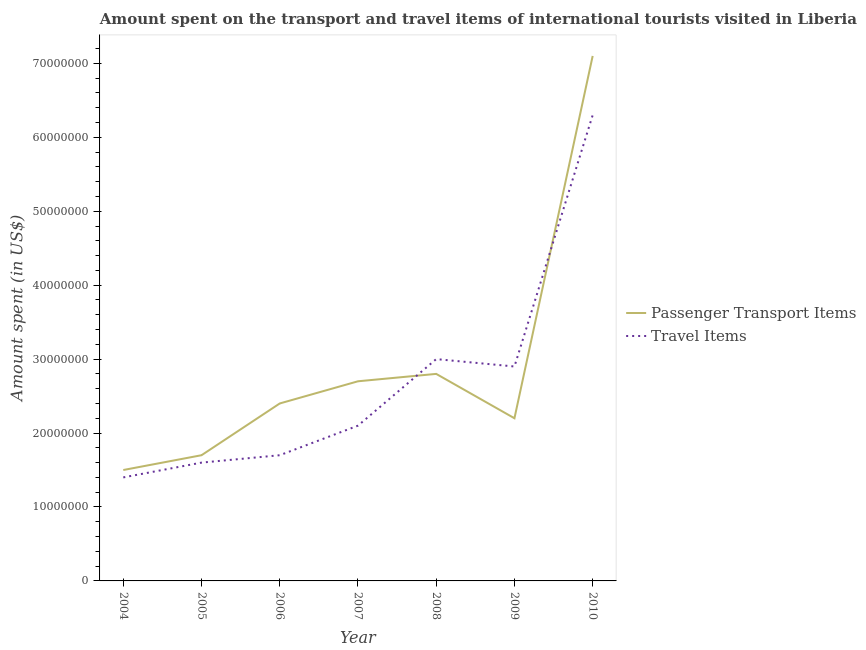How many different coloured lines are there?
Offer a terse response. 2. Is the number of lines equal to the number of legend labels?
Your answer should be very brief. Yes. What is the amount spent on passenger transport items in 2009?
Your response must be concise. 2.20e+07. Across all years, what is the maximum amount spent in travel items?
Your response must be concise. 6.30e+07. Across all years, what is the minimum amount spent in travel items?
Ensure brevity in your answer.  1.40e+07. In which year was the amount spent on passenger transport items maximum?
Your answer should be compact. 2010. In which year was the amount spent in travel items minimum?
Keep it short and to the point. 2004. What is the total amount spent in travel items in the graph?
Ensure brevity in your answer.  1.90e+08. What is the difference between the amount spent in travel items in 2008 and that in 2010?
Ensure brevity in your answer.  -3.30e+07. What is the difference between the amount spent in travel items in 2004 and the amount spent on passenger transport items in 2010?
Offer a terse response. -5.70e+07. What is the average amount spent on passenger transport items per year?
Give a very brief answer. 2.91e+07. In the year 2010, what is the difference between the amount spent on passenger transport items and amount spent in travel items?
Offer a very short reply. 8.00e+06. In how many years, is the amount spent on passenger transport items greater than 8000000 US$?
Your response must be concise. 7. What is the ratio of the amount spent in travel items in 2005 to that in 2006?
Provide a succinct answer. 0.94. Is the amount spent on passenger transport items in 2004 less than that in 2007?
Provide a short and direct response. Yes. What is the difference between the highest and the second highest amount spent in travel items?
Your answer should be compact. 3.30e+07. What is the difference between the highest and the lowest amount spent in travel items?
Offer a very short reply. 4.90e+07. In how many years, is the amount spent on passenger transport items greater than the average amount spent on passenger transport items taken over all years?
Your response must be concise. 1. Is the sum of the amount spent in travel items in 2005 and 2007 greater than the maximum amount spent on passenger transport items across all years?
Make the answer very short. No. Is the amount spent on passenger transport items strictly greater than the amount spent in travel items over the years?
Your answer should be compact. No. Is the amount spent in travel items strictly less than the amount spent on passenger transport items over the years?
Your answer should be compact. No. How many lines are there?
Offer a very short reply. 2. How many years are there in the graph?
Your answer should be compact. 7. Does the graph contain any zero values?
Provide a short and direct response. No. Does the graph contain grids?
Offer a very short reply. No. What is the title of the graph?
Keep it short and to the point. Amount spent on the transport and travel items of international tourists visited in Liberia. Does "Quality of trade" appear as one of the legend labels in the graph?
Offer a terse response. No. What is the label or title of the Y-axis?
Offer a terse response. Amount spent (in US$). What is the Amount spent (in US$) of Passenger Transport Items in 2004?
Your response must be concise. 1.50e+07. What is the Amount spent (in US$) in Travel Items in 2004?
Provide a succinct answer. 1.40e+07. What is the Amount spent (in US$) in Passenger Transport Items in 2005?
Make the answer very short. 1.70e+07. What is the Amount spent (in US$) in Travel Items in 2005?
Provide a short and direct response. 1.60e+07. What is the Amount spent (in US$) in Passenger Transport Items in 2006?
Offer a very short reply. 2.40e+07. What is the Amount spent (in US$) in Travel Items in 2006?
Make the answer very short. 1.70e+07. What is the Amount spent (in US$) of Passenger Transport Items in 2007?
Your answer should be very brief. 2.70e+07. What is the Amount spent (in US$) in Travel Items in 2007?
Your response must be concise. 2.10e+07. What is the Amount spent (in US$) of Passenger Transport Items in 2008?
Provide a succinct answer. 2.80e+07. What is the Amount spent (in US$) in Travel Items in 2008?
Provide a short and direct response. 3.00e+07. What is the Amount spent (in US$) of Passenger Transport Items in 2009?
Offer a terse response. 2.20e+07. What is the Amount spent (in US$) of Travel Items in 2009?
Your answer should be compact. 2.90e+07. What is the Amount spent (in US$) in Passenger Transport Items in 2010?
Ensure brevity in your answer.  7.10e+07. What is the Amount spent (in US$) in Travel Items in 2010?
Offer a very short reply. 6.30e+07. Across all years, what is the maximum Amount spent (in US$) of Passenger Transport Items?
Provide a short and direct response. 7.10e+07. Across all years, what is the maximum Amount spent (in US$) in Travel Items?
Offer a very short reply. 6.30e+07. Across all years, what is the minimum Amount spent (in US$) in Passenger Transport Items?
Your answer should be compact. 1.50e+07. Across all years, what is the minimum Amount spent (in US$) in Travel Items?
Offer a very short reply. 1.40e+07. What is the total Amount spent (in US$) in Passenger Transport Items in the graph?
Provide a short and direct response. 2.04e+08. What is the total Amount spent (in US$) in Travel Items in the graph?
Keep it short and to the point. 1.90e+08. What is the difference between the Amount spent (in US$) of Passenger Transport Items in 2004 and that in 2006?
Make the answer very short. -9.00e+06. What is the difference between the Amount spent (in US$) of Passenger Transport Items in 2004 and that in 2007?
Offer a terse response. -1.20e+07. What is the difference between the Amount spent (in US$) in Travel Items in 2004 and that in 2007?
Keep it short and to the point. -7.00e+06. What is the difference between the Amount spent (in US$) in Passenger Transport Items in 2004 and that in 2008?
Provide a short and direct response. -1.30e+07. What is the difference between the Amount spent (in US$) of Travel Items in 2004 and that in 2008?
Offer a terse response. -1.60e+07. What is the difference between the Amount spent (in US$) of Passenger Transport Items in 2004 and that in 2009?
Provide a succinct answer. -7.00e+06. What is the difference between the Amount spent (in US$) of Travel Items in 2004 and that in 2009?
Your response must be concise. -1.50e+07. What is the difference between the Amount spent (in US$) of Passenger Transport Items in 2004 and that in 2010?
Your answer should be compact. -5.60e+07. What is the difference between the Amount spent (in US$) in Travel Items in 2004 and that in 2010?
Your answer should be very brief. -4.90e+07. What is the difference between the Amount spent (in US$) of Passenger Transport Items in 2005 and that in 2006?
Keep it short and to the point. -7.00e+06. What is the difference between the Amount spent (in US$) in Passenger Transport Items in 2005 and that in 2007?
Make the answer very short. -1.00e+07. What is the difference between the Amount spent (in US$) in Travel Items in 2005 and that in 2007?
Provide a succinct answer. -5.00e+06. What is the difference between the Amount spent (in US$) of Passenger Transport Items in 2005 and that in 2008?
Offer a very short reply. -1.10e+07. What is the difference between the Amount spent (in US$) in Travel Items in 2005 and that in 2008?
Offer a very short reply. -1.40e+07. What is the difference between the Amount spent (in US$) in Passenger Transport Items in 2005 and that in 2009?
Your answer should be compact. -5.00e+06. What is the difference between the Amount spent (in US$) of Travel Items in 2005 and that in 2009?
Your answer should be very brief. -1.30e+07. What is the difference between the Amount spent (in US$) in Passenger Transport Items in 2005 and that in 2010?
Provide a succinct answer. -5.40e+07. What is the difference between the Amount spent (in US$) of Travel Items in 2005 and that in 2010?
Offer a terse response. -4.70e+07. What is the difference between the Amount spent (in US$) of Travel Items in 2006 and that in 2007?
Ensure brevity in your answer.  -4.00e+06. What is the difference between the Amount spent (in US$) of Travel Items in 2006 and that in 2008?
Provide a short and direct response. -1.30e+07. What is the difference between the Amount spent (in US$) in Travel Items in 2006 and that in 2009?
Give a very brief answer. -1.20e+07. What is the difference between the Amount spent (in US$) in Passenger Transport Items in 2006 and that in 2010?
Give a very brief answer. -4.70e+07. What is the difference between the Amount spent (in US$) of Travel Items in 2006 and that in 2010?
Ensure brevity in your answer.  -4.60e+07. What is the difference between the Amount spent (in US$) in Passenger Transport Items in 2007 and that in 2008?
Ensure brevity in your answer.  -1.00e+06. What is the difference between the Amount spent (in US$) of Travel Items in 2007 and that in 2008?
Make the answer very short. -9.00e+06. What is the difference between the Amount spent (in US$) in Travel Items in 2007 and that in 2009?
Give a very brief answer. -8.00e+06. What is the difference between the Amount spent (in US$) in Passenger Transport Items in 2007 and that in 2010?
Provide a succinct answer. -4.40e+07. What is the difference between the Amount spent (in US$) of Travel Items in 2007 and that in 2010?
Give a very brief answer. -4.20e+07. What is the difference between the Amount spent (in US$) of Passenger Transport Items in 2008 and that in 2010?
Offer a very short reply. -4.30e+07. What is the difference between the Amount spent (in US$) in Travel Items in 2008 and that in 2010?
Ensure brevity in your answer.  -3.30e+07. What is the difference between the Amount spent (in US$) of Passenger Transport Items in 2009 and that in 2010?
Make the answer very short. -4.90e+07. What is the difference between the Amount spent (in US$) of Travel Items in 2009 and that in 2010?
Offer a terse response. -3.40e+07. What is the difference between the Amount spent (in US$) of Passenger Transport Items in 2004 and the Amount spent (in US$) of Travel Items in 2006?
Your answer should be compact. -2.00e+06. What is the difference between the Amount spent (in US$) in Passenger Transport Items in 2004 and the Amount spent (in US$) in Travel Items in 2007?
Provide a short and direct response. -6.00e+06. What is the difference between the Amount spent (in US$) in Passenger Transport Items in 2004 and the Amount spent (in US$) in Travel Items in 2008?
Your response must be concise. -1.50e+07. What is the difference between the Amount spent (in US$) in Passenger Transport Items in 2004 and the Amount spent (in US$) in Travel Items in 2009?
Provide a succinct answer. -1.40e+07. What is the difference between the Amount spent (in US$) of Passenger Transport Items in 2004 and the Amount spent (in US$) of Travel Items in 2010?
Ensure brevity in your answer.  -4.80e+07. What is the difference between the Amount spent (in US$) in Passenger Transport Items in 2005 and the Amount spent (in US$) in Travel Items in 2006?
Your response must be concise. 0. What is the difference between the Amount spent (in US$) in Passenger Transport Items in 2005 and the Amount spent (in US$) in Travel Items in 2008?
Offer a very short reply. -1.30e+07. What is the difference between the Amount spent (in US$) in Passenger Transport Items in 2005 and the Amount spent (in US$) in Travel Items in 2009?
Give a very brief answer. -1.20e+07. What is the difference between the Amount spent (in US$) of Passenger Transport Items in 2005 and the Amount spent (in US$) of Travel Items in 2010?
Your answer should be very brief. -4.60e+07. What is the difference between the Amount spent (in US$) of Passenger Transport Items in 2006 and the Amount spent (in US$) of Travel Items in 2007?
Give a very brief answer. 3.00e+06. What is the difference between the Amount spent (in US$) of Passenger Transport Items in 2006 and the Amount spent (in US$) of Travel Items in 2008?
Offer a terse response. -6.00e+06. What is the difference between the Amount spent (in US$) of Passenger Transport Items in 2006 and the Amount spent (in US$) of Travel Items in 2009?
Make the answer very short. -5.00e+06. What is the difference between the Amount spent (in US$) of Passenger Transport Items in 2006 and the Amount spent (in US$) of Travel Items in 2010?
Give a very brief answer. -3.90e+07. What is the difference between the Amount spent (in US$) of Passenger Transport Items in 2007 and the Amount spent (in US$) of Travel Items in 2010?
Give a very brief answer. -3.60e+07. What is the difference between the Amount spent (in US$) of Passenger Transport Items in 2008 and the Amount spent (in US$) of Travel Items in 2010?
Make the answer very short. -3.50e+07. What is the difference between the Amount spent (in US$) of Passenger Transport Items in 2009 and the Amount spent (in US$) of Travel Items in 2010?
Give a very brief answer. -4.10e+07. What is the average Amount spent (in US$) in Passenger Transport Items per year?
Give a very brief answer. 2.91e+07. What is the average Amount spent (in US$) in Travel Items per year?
Ensure brevity in your answer.  2.71e+07. In the year 2005, what is the difference between the Amount spent (in US$) of Passenger Transport Items and Amount spent (in US$) of Travel Items?
Provide a succinct answer. 1.00e+06. In the year 2006, what is the difference between the Amount spent (in US$) of Passenger Transport Items and Amount spent (in US$) of Travel Items?
Ensure brevity in your answer.  7.00e+06. In the year 2008, what is the difference between the Amount spent (in US$) of Passenger Transport Items and Amount spent (in US$) of Travel Items?
Offer a terse response. -2.00e+06. In the year 2009, what is the difference between the Amount spent (in US$) of Passenger Transport Items and Amount spent (in US$) of Travel Items?
Ensure brevity in your answer.  -7.00e+06. In the year 2010, what is the difference between the Amount spent (in US$) in Passenger Transport Items and Amount spent (in US$) in Travel Items?
Provide a succinct answer. 8.00e+06. What is the ratio of the Amount spent (in US$) in Passenger Transport Items in 2004 to that in 2005?
Offer a terse response. 0.88. What is the ratio of the Amount spent (in US$) of Travel Items in 2004 to that in 2005?
Ensure brevity in your answer.  0.88. What is the ratio of the Amount spent (in US$) in Passenger Transport Items in 2004 to that in 2006?
Keep it short and to the point. 0.62. What is the ratio of the Amount spent (in US$) of Travel Items in 2004 to that in 2006?
Provide a short and direct response. 0.82. What is the ratio of the Amount spent (in US$) in Passenger Transport Items in 2004 to that in 2007?
Your answer should be compact. 0.56. What is the ratio of the Amount spent (in US$) of Travel Items in 2004 to that in 2007?
Provide a short and direct response. 0.67. What is the ratio of the Amount spent (in US$) in Passenger Transport Items in 2004 to that in 2008?
Make the answer very short. 0.54. What is the ratio of the Amount spent (in US$) of Travel Items in 2004 to that in 2008?
Your response must be concise. 0.47. What is the ratio of the Amount spent (in US$) in Passenger Transport Items in 2004 to that in 2009?
Provide a short and direct response. 0.68. What is the ratio of the Amount spent (in US$) in Travel Items in 2004 to that in 2009?
Provide a short and direct response. 0.48. What is the ratio of the Amount spent (in US$) of Passenger Transport Items in 2004 to that in 2010?
Provide a short and direct response. 0.21. What is the ratio of the Amount spent (in US$) of Travel Items in 2004 to that in 2010?
Offer a very short reply. 0.22. What is the ratio of the Amount spent (in US$) in Passenger Transport Items in 2005 to that in 2006?
Your answer should be compact. 0.71. What is the ratio of the Amount spent (in US$) in Travel Items in 2005 to that in 2006?
Make the answer very short. 0.94. What is the ratio of the Amount spent (in US$) in Passenger Transport Items in 2005 to that in 2007?
Make the answer very short. 0.63. What is the ratio of the Amount spent (in US$) in Travel Items in 2005 to that in 2007?
Give a very brief answer. 0.76. What is the ratio of the Amount spent (in US$) in Passenger Transport Items in 2005 to that in 2008?
Provide a short and direct response. 0.61. What is the ratio of the Amount spent (in US$) in Travel Items in 2005 to that in 2008?
Provide a succinct answer. 0.53. What is the ratio of the Amount spent (in US$) in Passenger Transport Items in 2005 to that in 2009?
Offer a very short reply. 0.77. What is the ratio of the Amount spent (in US$) in Travel Items in 2005 to that in 2009?
Your answer should be compact. 0.55. What is the ratio of the Amount spent (in US$) in Passenger Transport Items in 2005 to that in 2010?
Your answer should be very brief. 0.24. What is the ratio of the Amount spent (in US$) of Travel Items in 2005 to that in 2010?
Make the answer very short. 0.25. What is the ratio of the Amount spent (in US$) of Passenger Transport Items in 2006 to that in 2007?
Offer a terse response. 0.89. What is the ratio of the Amount spent (in US$) in Travel Items in 2006 to that in 2007?
Ensure brevity in your answer.  0.81. What is the ratio of the Amount spent (in US$) in Passenger Transport Items in 2006 to that in 2008?
Give a very brief answer. 0.86. What is the ratio of the Amount spent (in US$) in Travel Items in 2006 to that in 2008?
Your response must be concise. 0.57. What is the ratio of the Amount spent (in US$) of Passenger Transport Items in 2006 to that in 2009?
Offer a terse response. 1.09. What is the ratio of the Amount spent (in US$) in Travel Items in 2006 to that in 2009?
Provide a short and direct response. 0.59. What is the ratio of the Amount spent (in US$) in Passenger Transport Items in 2006 to that in 2010?
Keep it short and to the point. 0.34. What is the ratio of the Amount spent (in US$) in Travel Items in 2006 to that in 2010?
Offer a very short reply. 0.27. What is the ratio of the Amount spent (in US$) of Passenger Transport Items in 2007 to that in 2009?
Provide a succinct answer. 1.23. What is the ratio of the Amount spent (in US$) in Travel Items in 2007 to that in 2009?
Make the answer very short. 0.72. What is the ratio of the Amount spent (in US$) in Passenger Transport Items in 2007 to that in 2010?
Your answer should be compact. 0.38. What is the ratio of the Amount spent (in US$) of Travel Items in 2007 to that in 2010?
Ensure brevity in your answer.  0.33. What is the ratio of the Amount spent (in US$) in Passenger Transport Items in 2008 to that in 2009?
Provide a succinct answer. 1.27. What is the ratio of the Amount spent (in US$) in Travel Items in 2008 to that in 2009?
Your answer should be very brief. 1.03. What is the ratio of the Amount spent (in US$) of Passenger Transport Items in 2008 to that in 2010?
Your response must be concise. 0.39. What is the ratio of the Amount spent (in US$) in Travel Items in 2008 to that in 2010?
Give a very brief answer. 0.48. What is the ratio of the Amount spent (in US$) in Passenger Transport Items in 2009 to that in 2010?
Your answer should be very brief. 0.31. What is the ratio of the Amount spent (in US$) in Travel Items in 2009 to that in 2010?
Offer a terse response. 0.46. What is the difference between the highest and the second highest Amount spent (in US$) of Passenger Transport Items?
Keep it short and to the point. 4.30e+07. What is the difference between the highest and the second highest Amount spent (in US$) in Travel Items?
Provide a short and direct response. 3.30e+07. What is the difference between the highest and the lowest Amount spent (in US$) in Passenger Transport Items?
Your response must be concise. 5.60e+07. What is the difference between the highest and the lowest Amount spent (in US$) of Travel Items?
Your answer should be very brief. 4.90e+07. 